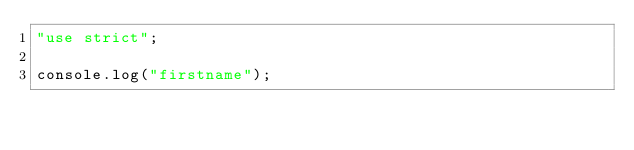<code> <loc_0><loc_0><loc_500><loc_500><_JavaScript_>"use strict";

console.log("firstname");</code> 